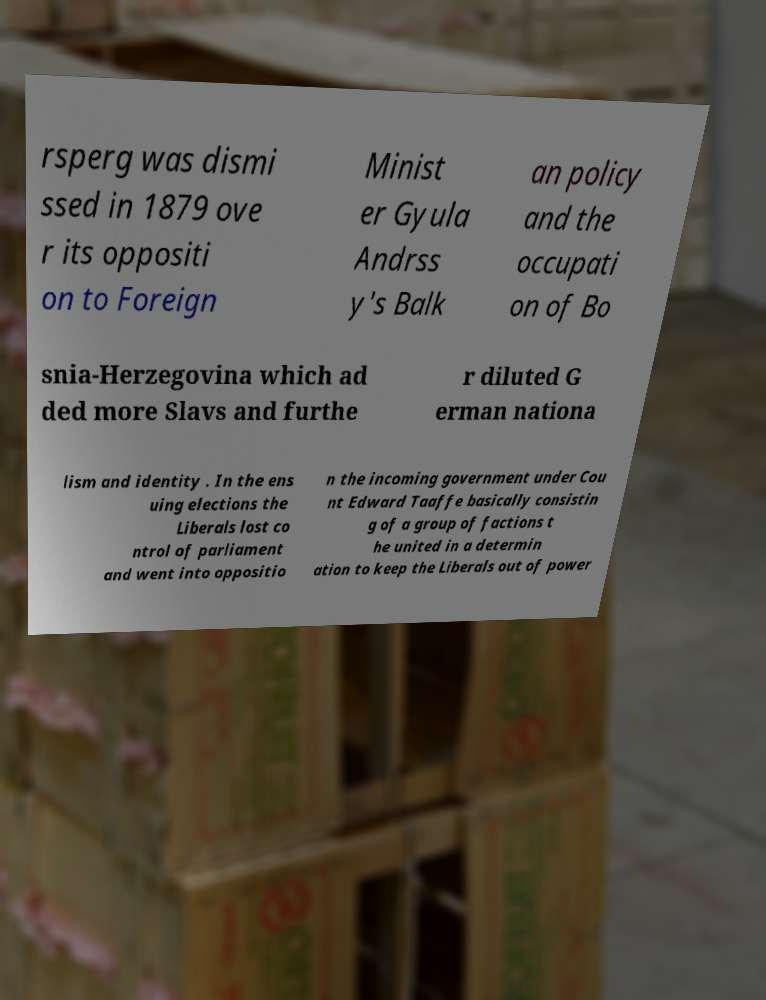What messages or text are displayed in this image? I need them in a readable, typed format. rsperg was dismi ssed in 1879 ove r its oppositi on to Foreign Minist er Gyula Andrss y's Balk an policy and the occupati on of Bo snia-Herzegovina which ad ded more Slavs and furthe r diluted G erman nationa lism and identity . In the ens uing elections the Liberals lost co ntrol of parliament and went into oppositio n the incoming government under Cou nt Edward Taaffe basically consistin g of a group of factions t he united in a determin ation to keep the Liberals out of power 